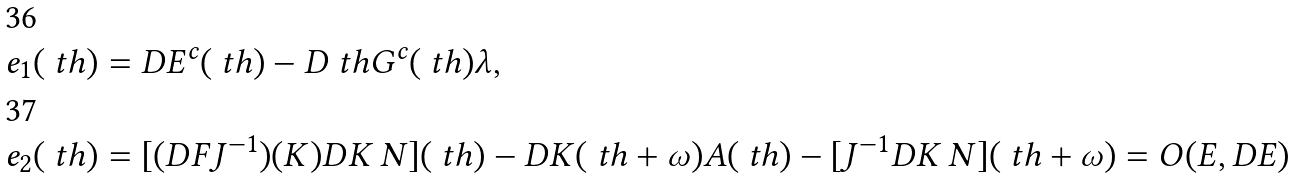Convert formula to latex. <formula><loc_0><loc_0><loc_500><loc_500>& e _ { 1 } ( \ t h ) = D E ^ { c } ( \ t h ) - D _ { \ } t h G ^ { c } ( \ t h ) \lambda , \\ & e _ { 2 } ( \ t h ) = [ ( D F J ^ { - 1 } ) ( K ) D K \, N ] ( \ t h ) - D K ( \ t h + \omega ) A ( \ t h ) - [ J ^ { - 1 } D K \, N ] ( \ t h + \omega ) = O ( E , D E )</formula> 